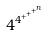<formula> <loc_0><loc_0><loc_500><loc_500>4 ^ { 4 ^ { + ^ { + ^ { + ^ { n } } } } }</formula> 